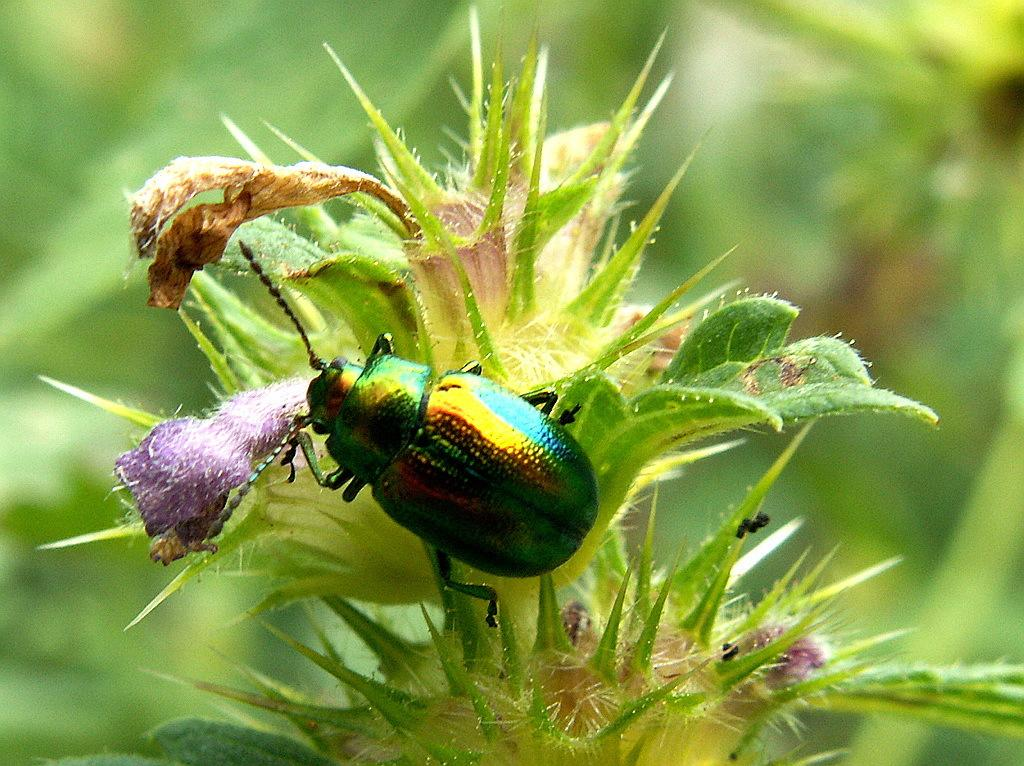What is located in the front of the image? There is a plant and an insect in the front of the image. Can you describe the plant in the image? Unfortunately, the facts provided do not give any details about the plant. What can be seen in the background of the image? The background of the image is blurry. How many servants are attending to the plant in the image? There are no servants present in the image. What word is written on the insect in the image? There are no words written on the insect in the image. 